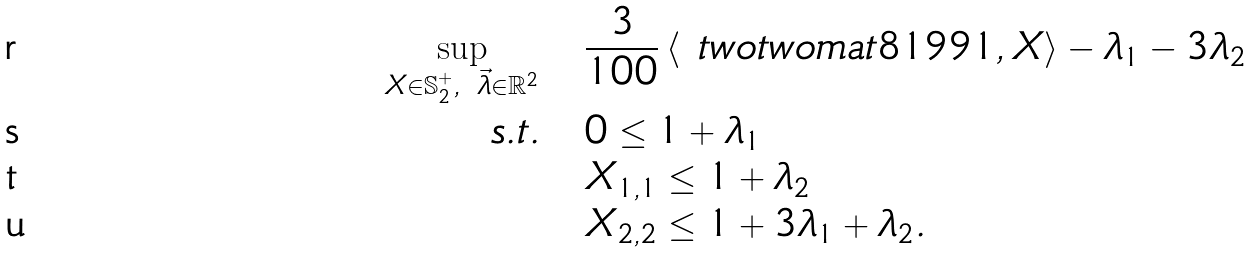<formula> <loc_0><loc_0><loc_500><loc_500>\sup _ { X \in \mathbb { S } _ { 2 } ^ { + } , \ \vec { \lambda } \in \mathbb { R } ^ { 2 } } & \quad \frac { 3 } { 1 0 0 } \left \langle \ t w o t w o m a t { 8 1 } { 9 } { 9 } { 1 } , X \right \rangle - \lambda _ { 1 } - 3 \lambda _ { 2 } \\ s . t . & \quad 0 \leq 1 + \lambda _ { 1 } \\ & \quad X _ { 1 , 1 } \leq 1 + \lambda _ { 2 } \\ & \quad X _ { 2 , 2 } \leq 1 + 3 \lambda _ { 1 } + \lambda _ { 2 } .</formula> 